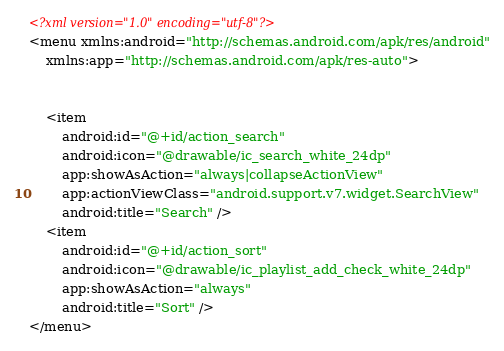Convert code to text. <code><loc_0><loc_0><loc_500><loc_500><_XML_><?xml version="1.0" encoding="utf-8"?>
<menu xmlns:android="http://schemas.android.com/apk/res/android"
    xmlns:app="http://schemas.android.com/apk/res-auto">


    <item
        android:id="@+id/action_search"
        android:icon="@drawable/ic_search_white_24dp"
        app:showAsAction="always|collapseActionView"
        app:actionViewClass="android.support.v7.widget.SearchView"
        android:title="Search" />
    <item
        android:id="@+id/action_sort"
        android:icon="@drawable/ic_playlist_add_check_white_24dp"
        app:showAsAction="always"
        android:title="Sort" />
</menu>
</code> 